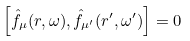<formula> <loc_0><loc_0><loc_500><loc_500>\left [ \hat { f } _ { \mu } ( { r } , \omega ) , \hat { f } _ { \mu ^ { \prime } } ( { r } ^ { \prime } , \omega ^ { \prime } ) \right ] = 0</formula> 